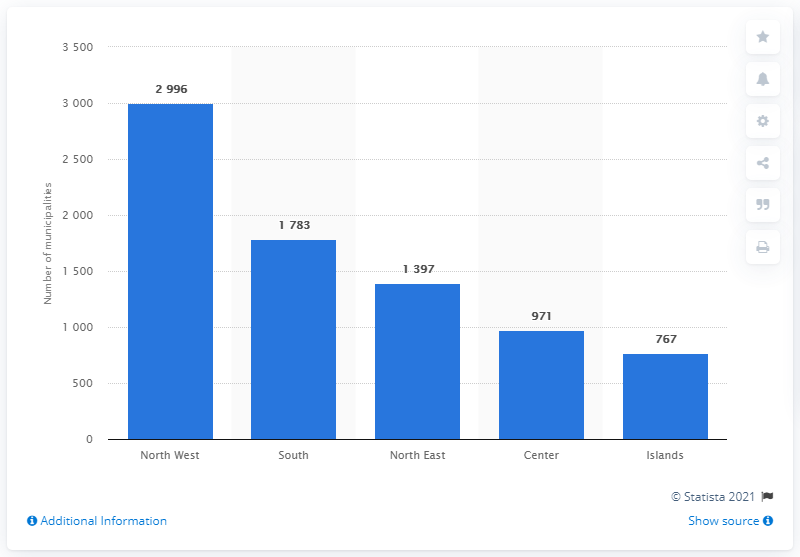Point out several critical features in this image. There were 767 municipalities in the islands in 2020. 